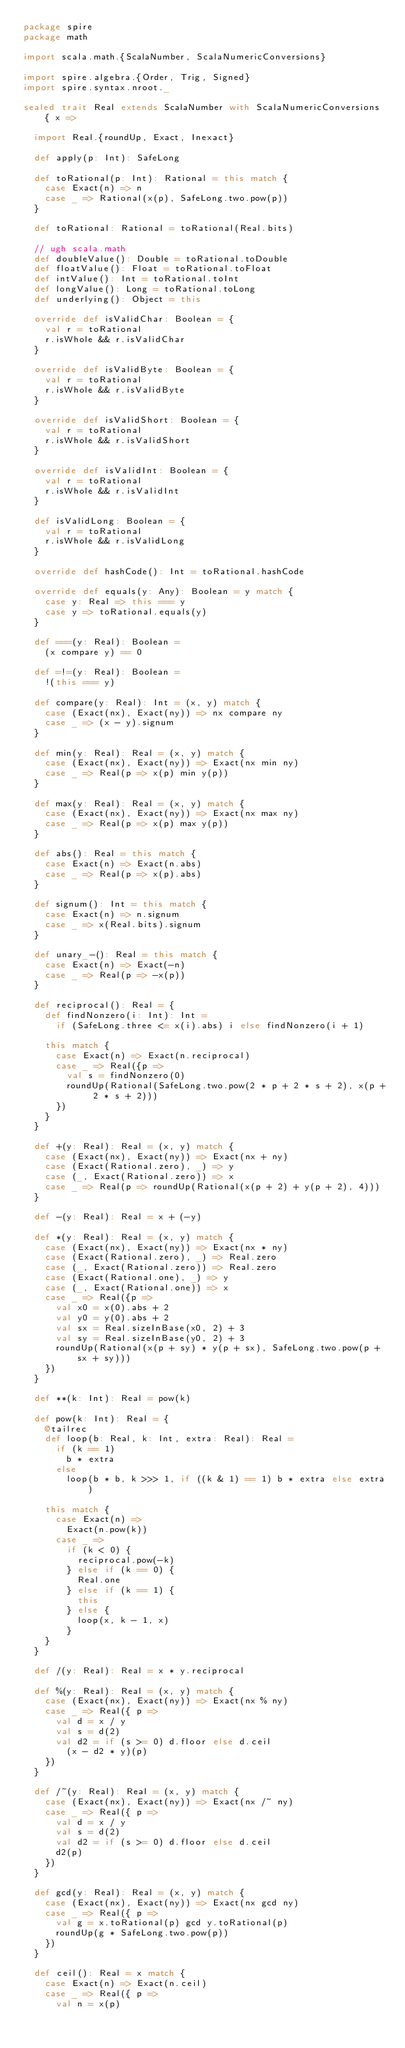Convert code to text. <code><loc_0><loc_0><loc_500><loc_500><_Scala_>package spire
package math

import scala.math.{ScalaNumber, ScalaNumericConversions}

import spire.algebra.{Order, Trig, Signed}
import spire.syntax.nroot._

sealed trait Real extends ScalaNumber with ScalaNumericConversions { x =>

  import Real.{roundUp, Exact, Inexact}

  def apply(p: Int): SafeLong

  def toRational(p: Int): Rational = this match {
    case Exact(n) => n
    case _ => Rational(x(p), SafeLong.two.pow(p))
  }

  def toRational: Rational = toRational(Real.bits)

  // ugh scala.math
  def doubleValue(): Double = toRational.toDouble
  def floatValue(): Float = toRational.toFloat
  def intValue(): Int = toRational.toInt
  def longValue(): Long = toRational.toLong
  def underlying(): Object = this

  override def isValidChar: Boolean = {
    val r = toRational
    r.isWhole && r.isValidChar
  }

  override def isValidByte: Boolean = {
    val r = toRational
    r.isWhole && r.isValidByte
  }

  override def isValidShort: Boolean = {
    val r = toRational
    r.isWhole && r.isValidShort
  }

  override def isValidInt: Boolean = {
    val r = toRational
    r.isWhole && r.isValidInt
  }

  def isValidLong: Boolean = {
    val r = toRational
    r.isWhole && r.isValidLong
  }

  override def hashCode(): Int = toRational.hashCode

  override def equals(y: Any): Boolean = y match {
    case y: Real => this === y
    case y => toRational.equals(y)
  }

  def ===(y: Real): Boolean =
    (x compare y) == 0

  def =!=(y: Real): Boolean =
    !(this === y)

  def compare(y: Real): Int = (x, y) match {
    case (Exact(nx), Exact(ny)) => nx compare ny
    case _ => (x - y).signum
  }

  def min(y: Real): Real = (x, y) match {
    case (Exact(nx), Exact(ny)) => Exact(nx min ny)
    case _ => Real(p => x(p) min y(p))
  }

  def max(y: Real): Real = (x, y) match {
    case (Exact(nx), Exact(ny)) => Exact(nx max ny)
    case _ => Real(p => x(p) max y(p))
  }

  def abs(): Real = this match {
    case Exact(n) => Exact(n.abs)
    case _ => Real(p => x(p).abs)
  }

  def signum(): Int = this match {
    case Exact(n) => n.signum
    case _ => x(Real.bits).signum
  }

  def unary_-(): Real = this match {
    case Exact(n) => Exact(-n)
    case _ => Real(p => -x(p))
  }

  def reciprocal(): Real = {
    def findNonzero(i: Int): Int =
      if (SafeLong.three <= x(i).abs) i else findNonzero(i + 1)

    this match {
      case Exact(n) => Exact(n.reciprocal)
      case _ => Real({p =>
        val s = findNonzero(0)
        roundUp(Rational(SafeLong.two.pow(2 * p + 2 * s + 2), x(p + 2 * s + 2)))
      })
    }
  }

  def +(y: Real): Real = (x, y) match {
    case (Exact(nx), Exact(ny)) => Exact(nx + ny)
    case (Exact(Rational.zero), _) => y
    case (_, Exact(Rational.zero)) => x
    case _ => Real(p => roundUp(Rational(x(p + 2) + y(p + 2), 4)))
  }

  def -(y: Real): Real = x + (-y)

  def *(y: Real): Real = (x, y) match {
    case (Exact(nx), Exact(ny)) => Exact(nx * ny)
    case (Exact(Rational.zero), _) => Real.zero
    case (_, Exact(Rational.zero)) => Real.zero
    case (Exact(Rational.one), _) => y
    case (_, Exact(Rational.one)) => x
    case _ => Real({p =>
      val x0 = x(0).abs + 2
      val y0 = y(0).abs + 2
      val sx = Real.sizeInBase(x0, 2) + 3
      val sy = Real.sizeInBase(y0, 2) + 3
      roundUp(Rational(x(p + sy) * y(p + sx), SafeLong.two.pow(p + sx + sy)))
    })
  }

  def **(k: Int): Real = pow(k)

  def pow(k: Int): Real = {
    @tailrec
    def loop(b: Real, k: Int, extra: Real): Real =
      if (k == 1)
        b * extra
      else
        loop(b * b, k >>> 1, if ((k & 1) == 1) b * extra else extra)

    this match {
      case Exact(n) =>
        Exact(n.pow(k))
      case _ =>
        if (k < 0) {
          reciprocal.pow(-k)
        } else if (k == 0) {
          Real.one
        } else if (k == 1) {
          this
        } else {
          loop(x, k - 1, x)
        }
    }
  }

  def /(y: Real): Real = x * y.reciprocal

  def %(y: Real): Real = (x, y) match {
    case (Exact(nx), Exact(ny)) => Exact(nx % ny)
    case _ => Real({ p =>
      val d = x / y
      val s = d(2)
      val d2 = if (s >= 0) d.floor else d.ceil
        (x - d2 * y)(p)
    })
  }

  def /~(y: Real): Real = (x, y) match {
    case (Exact(nx), Exact(ny)) => Exact(nx /~ ny)
    case _ => Real({ p =>
      val d = x / y
      val s = d(2)
      val d2 = if (s >= 0) d.floor else d.ceil
      d2(p)
    })
  }

  def gcd(y: Real): Real = (x, y) match {
    case (Exact(nx), Exact(ny)) => Exact(nx gcd ny)
    case _ => Real({ p =>
      val g = x.toRational(p) gcd y.toRational(p)
      roundUp(g * SafeLong.two.pow(p))
    })
  }

  def ceil(): Real = x match {
    case Exact(n) => Exact(n.ceil)
    case _ => Real({ p =>
      val n = x(p)</code> 